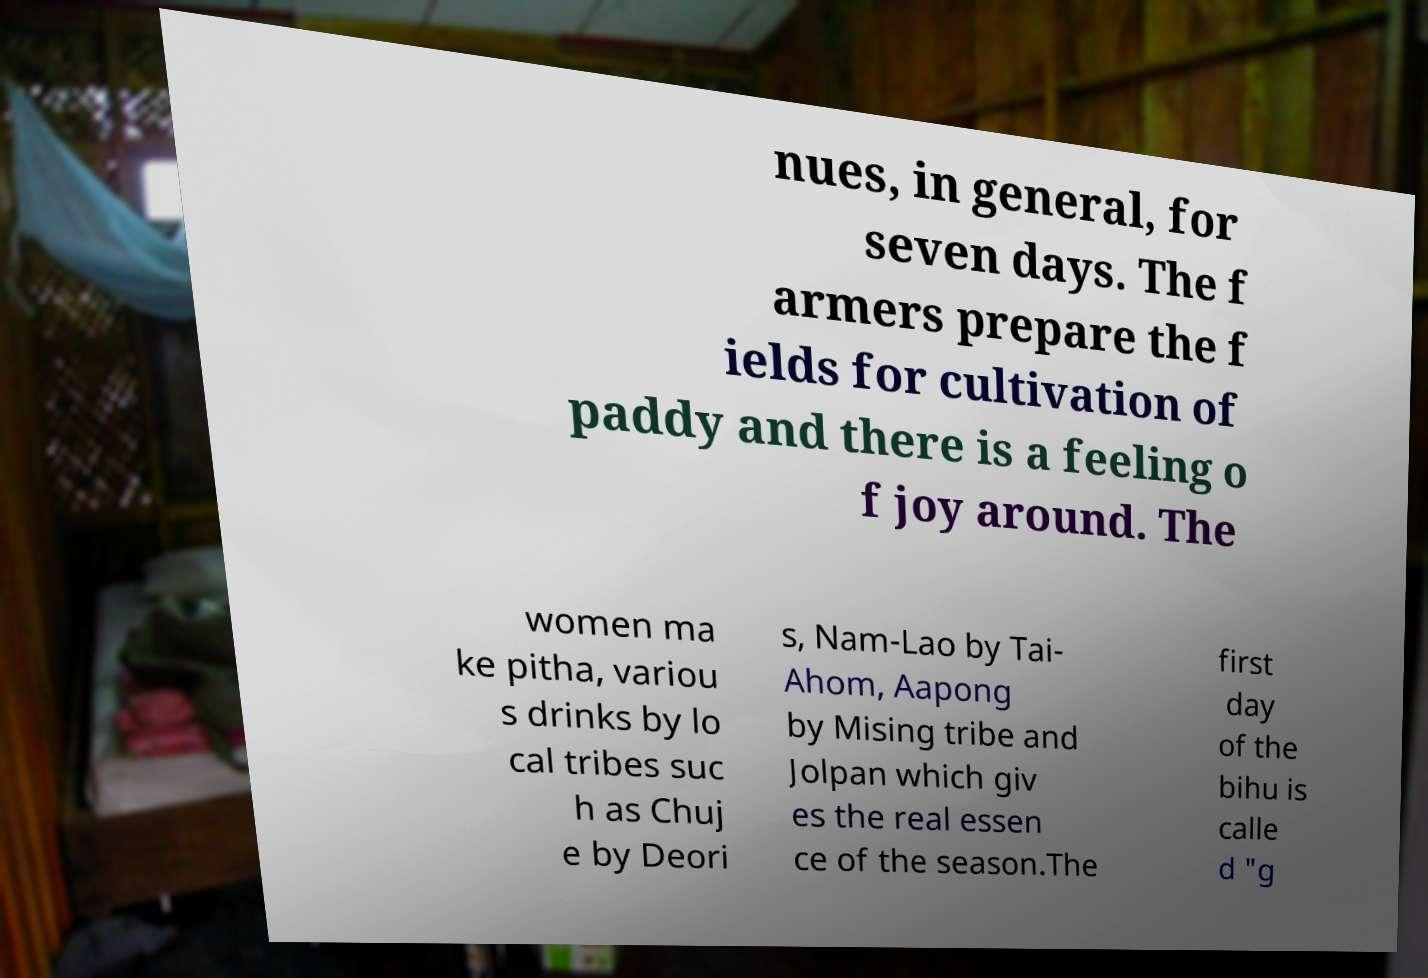Please identify and transcribe the text found in this image. nues, in general, for seven days. The f armers prepare the f ields for cultivation of paddy and there is a feeling o f joy around. The women ma ke pitha, variou s drinks by lo cal tribes suc h as Chuj e by Deori s, Nam-Lao by Tai- Ahom, Aapong by Mising tribe and Jolpan which giv es the real essen ce of the season.The first day of the bihu is calle d "g 